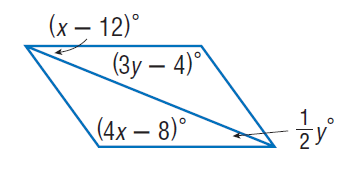Answer the mathemtical geometry problem and directly provide the correct option letter.
Question: Find y so that the quadrilateral is a parallelogram.
Choices: A: 22 B: 44 C: 88 D: 128 B 